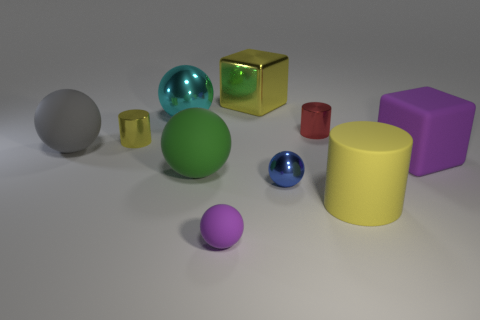Subtract all purple spheres. How many spheres are left? 4 Subtract all green cubes. How many yellow cylinders are left? 2 Subtract all green spheres. How many spheres are left? 4 Subtract 1 cylinders. How many cylinders are left? 2 Subtract all purple balls. Subtract all red cubes. How many balls are left? 4 Add 9 purple blocks. How many purple blocks exist? 10 Subtract 0 gray cylinders. How many objects are left? 10 Subtract all cylinders. How many objects are left? 7 Subtract all large yellow metal objects. Subtract all large green rubber objects. How many objects are left? 8 Add 8 large yellow blocks. How many large yellow blocks are left? 9 